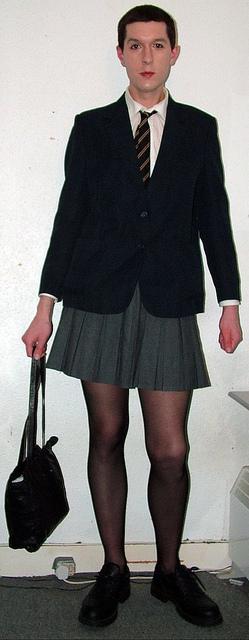What gender is this person?
Answer briefly. Male. What is the man holding in his right hand?
Concise answer only. Purse. Is this person modeling?
Quick response, please. Yes. 